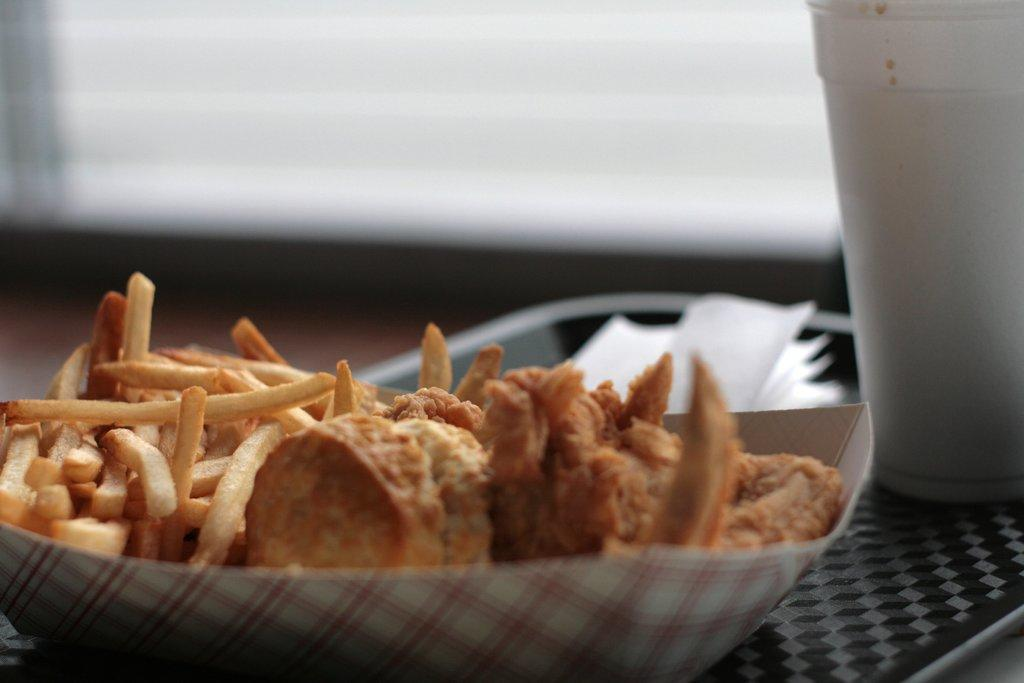What type of container holds the food in the image? There is food in a box in the image. What other item is located near the box? There is a glass beside the box. What can be used for cleaning or wiping in the image? Tissue papers are present in the image. How are the food, glass, and tissue papers arranged in the image? All these items are in a tray. What can be said about the background of the image? The background of the image is blurry. Can you see a tiger walking in the background of the image? There is no tiger present in the image, and the background is blurry, so it is not possible to see any animals walking. 